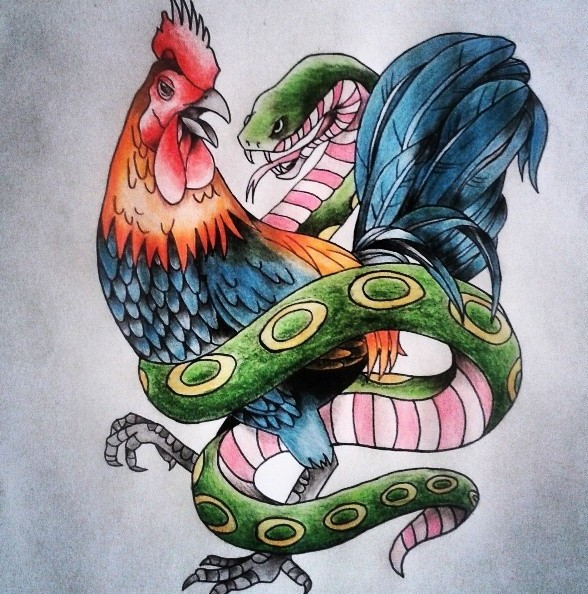Let's imagine the rooster and the snake were once part of an epic myth from an ancient civilization. What might their story be? In an epic myth from an ancient civilization, the rooster and the snake could be featured as embodiments of celestial and terrestrial forces, respectively. According to the legend, the rooster was a solar deity, heralding the new dawn and bringing light to the world. The snake, as a guardian of the underworld, commanded wisdom and the secret knowledge of the earth. Their paths crossed in a prophesied cycle, where every millennia, they would intertwine in a cosmic dance to restore balance to the world. This myth could center around their monumental battle, which, despite its ferocity, was necessary to renew the life forces of the universe. Their entwining represents not just conflict but the cyclical nature of time and existence, reminding civilizations of their place in the overarching tapestry of creation. What role might human characters play in such a myth? Human characters in this myth might serve as intermediaries or champions chosen by the rooster and snake to safeguard and maintain balance on earth. These individuals could be seen as heroes or sages, tasked with understanding the deeper wisdom these animals symbolize and ensuring that their powers are kept in equilibrium. They might undertake epic quests or trials, seeking relics imbued with the essence of the rooster and snake, attempting to unify or reconcile the opposing forces. Their journey would be a testament to human resilience, wisdom, and the pursuit of harmony with nature's dualistic aspects. 